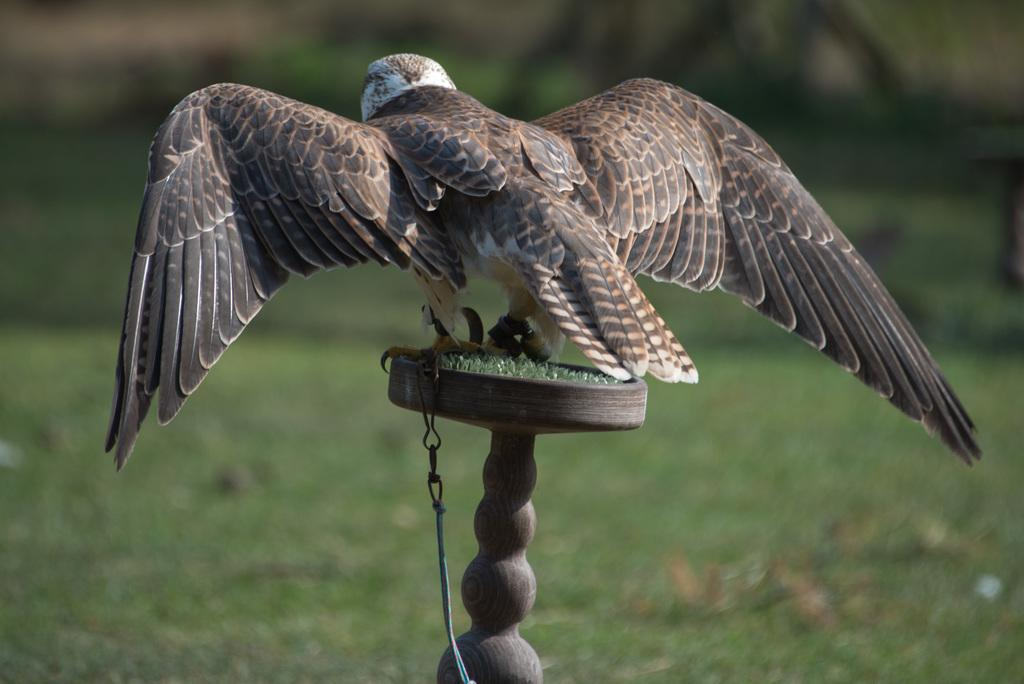What is standing on the table in the image? There is a bird standing on the table in the image. What is unique about the bird's appearance? The bird has a chain connected to its legs. What can be seen in the background of the image? There is ground visible in the background of the image. What type of underwear is the bird wearing in the image? There is no underwear present in the image, as the bird is a bird and does not wear clothing. 